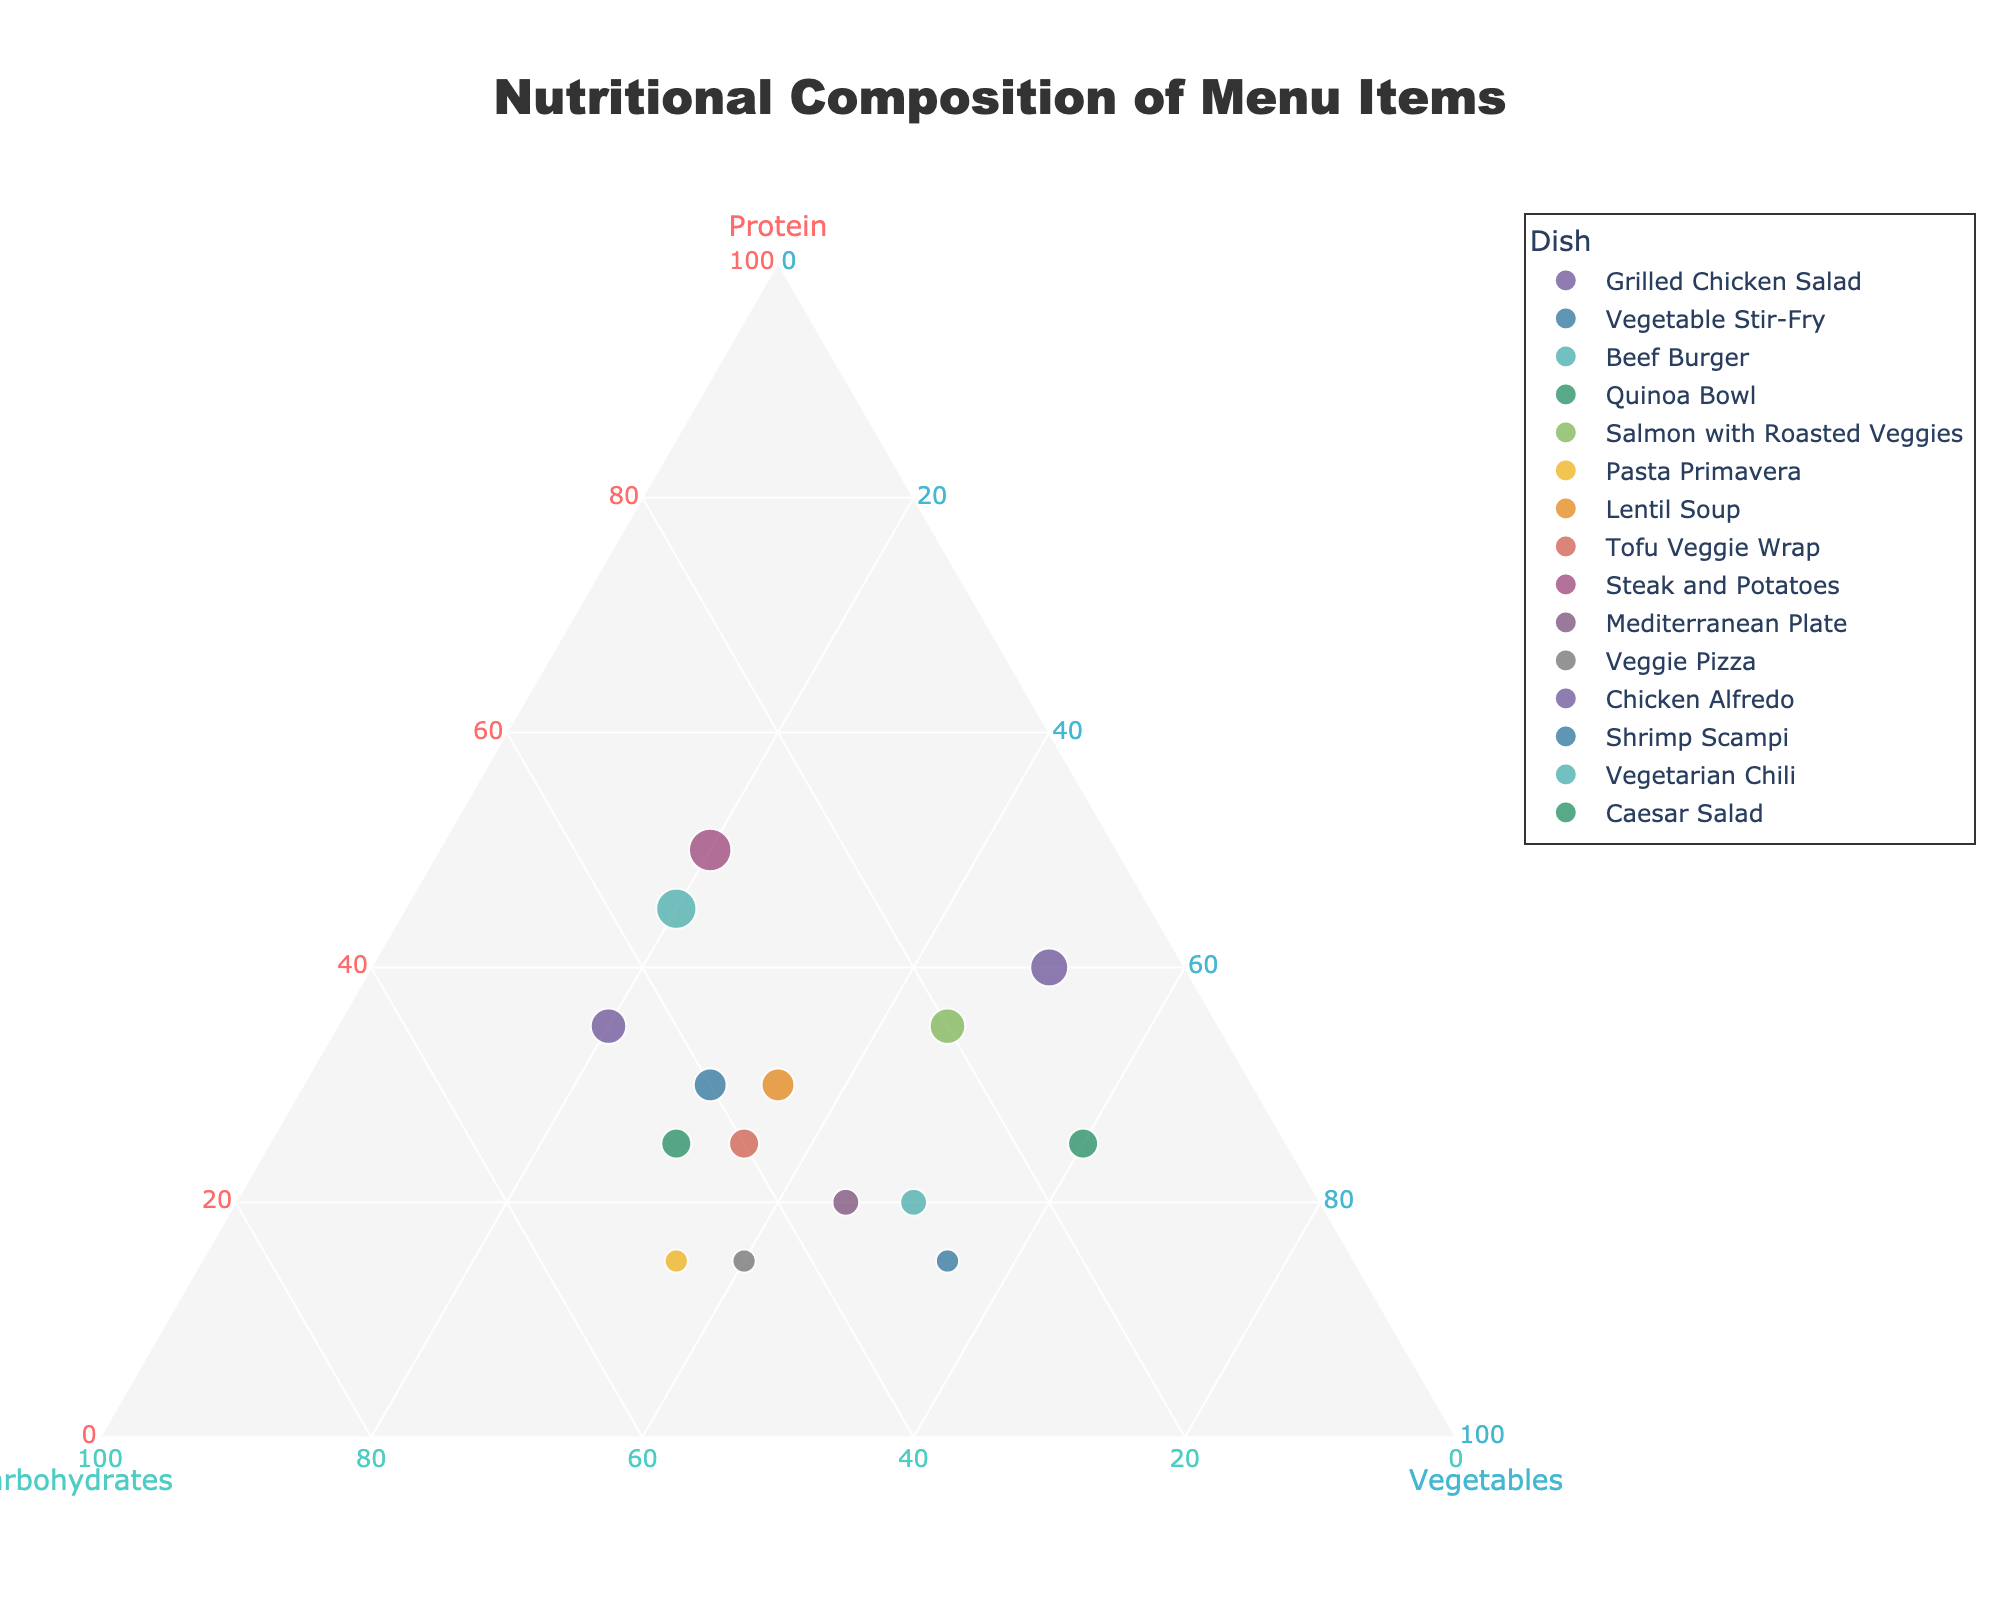What is the title of the plot? The title of the plot is located at the top and center of the figure. It should be readable and clearly describe the plot's content.
Answer: Nutritional Composition of Menu Items Which dish has the highest protein content? To find the dish with the highest protein content, locate the data point closest to the "Protein" axis.
Answer: Steak and Potatoes Identify the dish with the highest proportion of vegetables. The dish with the highest proportion of vegetables will be the closest to the "Vegetables" axis.
Answer: Caesar Salad How many dishes have a higher carbohydrate content than protein content? Compare each dish's position relative to the "Carbohydrates" and "Protein" axes. Count the number of dishes where the carbohydrate content is greater.
Answer: 6 Which dish has equal proportions of protein, carbohydrates, and vegetables? Look for a data point positioned exactly in the center of the ternary plot, where all three components are equal.
Answer: Lentil Soup Compare the carbohydrate content between "Shrimp Scampi" and "Chicken Alfredo". Which one is higher? Locate "Shrimp Scampi" and "Chicken Alfredo" on the plot. Compare their positions relative to the "Carbohydrates" axis.
Answer: Chicken Alfredo What is the average protein content of "Grilled Chicken Salad" and "Beef Burger"? Average the protein contents of these two dishes (40% and 45%).
Answer: 42.5% Which two dishes are closest to each other in terms of nutritional composition? Look for data points that are situated nearest to each other on the plot, indicating similar proportions of protein, carbohydrates, and vegetables.
Answer: Tofu Veggie Wrap and Shrimp Scampi Explain why "Vegetarian Chili" and "Caesar Salad" are positioned far apart on the plot. Analyze their nutritional compositions. "Vegetarian Chili" has significant carbs and protein but fewer vegetables compared to "Caesar Salad", which is heavy on vegetables and light on protein and carbs. This difference spreads them across the plot.
Answer: Significant differences in their nutritional compositions Calculate the total percentage of vegetables for "Vegetable Stir-Fry" and "Pasta Primavera". Sum the vegetable content of these two dishes (55% and 35%).
Answer: 90% 